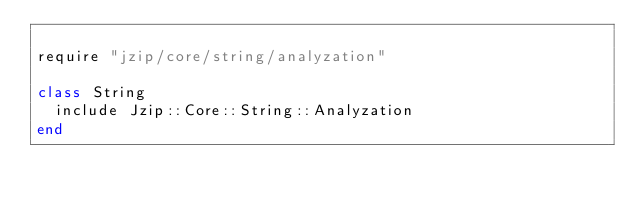Convert code to text. <code><loc_0><loc_0><loc_500><loc_500><_Ruby_>
require "jzip/core/string/analyzation"

class String
  include Jzip::Core::String::Analyzation
end
</code> 